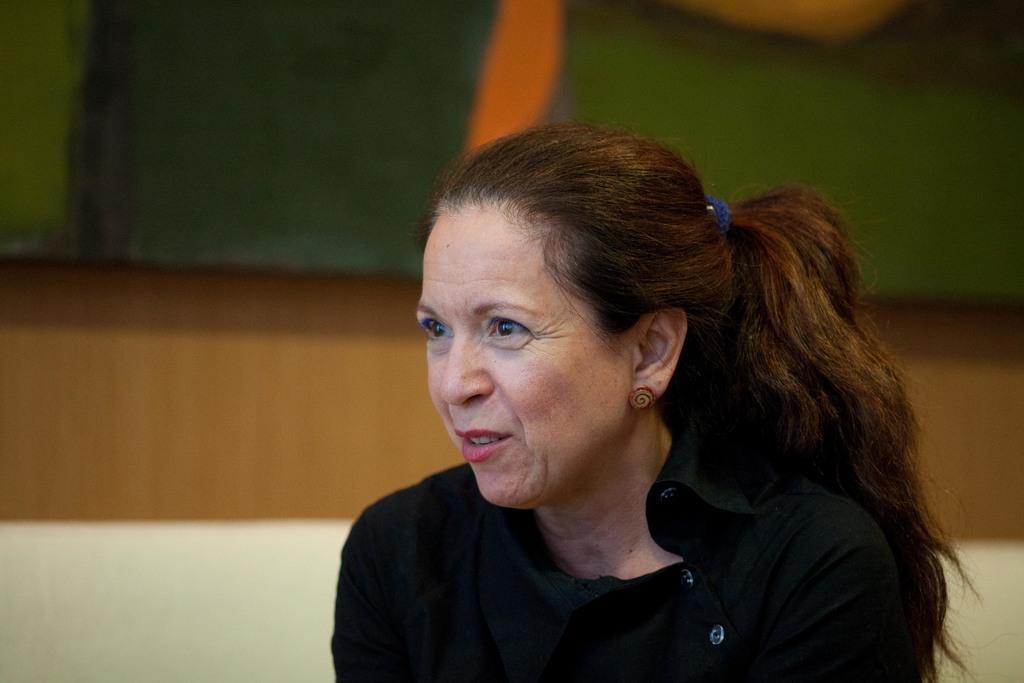Describe this image in one or two sentences. In the picture I can see a woman is wearing black color clothes. The background of the image is blurred. 